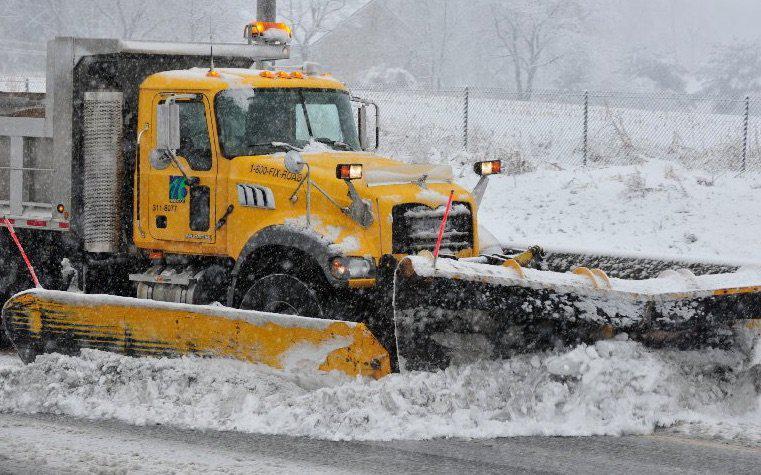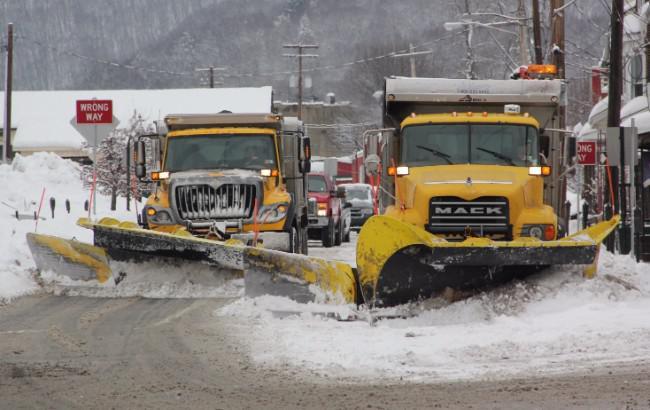The first image is the image on the left, the second image is the image on the right. For the images displayed, is the sentence "There are no fewer than 4 vehicles on the road." factually correct? Answer yes or no. Yes. The first image is the image on the left, the second image is the image on the right. Considering the images on both sides, is "The left and right image contains a total of three snow trucks." valid? Answer yes or no. Yes. 